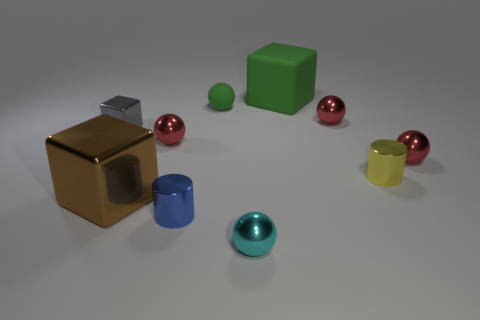What number of matte objects are there?
Provide a succinct answer. 2. How many yellow objects are metal blocks or cubes?
Give a very brief answer. 0. What number of other objects are there of the same shape as the large green thing?
Provide a succinct answer. 2. There is a cube that is to the right of the large brown metallic block; is it the same color as the rubber thing that is left of the cyan ball?
Make the answer very short. Yes. What number of small things are red metallic balls or metallic cylinders?
Offer a very short reply. 5. There is a rubber thing that is the same shape as the big brown shiny thing; what size is it?
Keep it short and to the point. Large. There is a thing that is left of the large block in front of the tiny green rubber ball; what is its material?
Provide a succinct answer. Metal. How many matte objects are either big blocks or spheres?
Your answer should be compact. 2. What color is the small object that is the same shape as the large metal thing?
Ensure brevity in your answer.  Gray. What number of matte spheres have the same color as the large rubber block?
Keep it short and to the point. 1. 